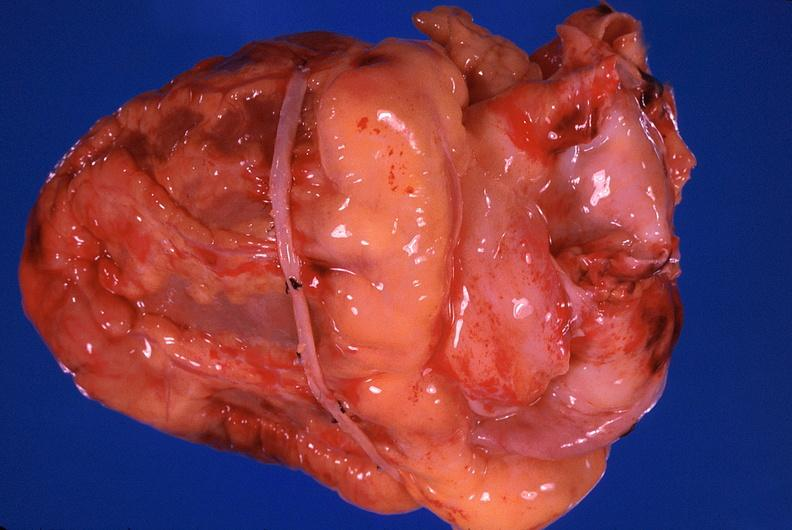does this image show heart, recent coronary artery bypass graft?
Answer the question using a single word or phrase. Yes 